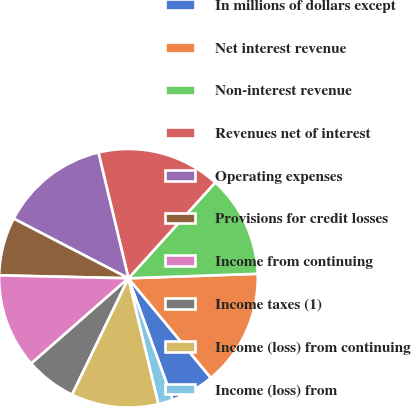Convert chart. <chart><loc_0><loc_0><loc_500><loc_500><pie_chart><fcel>In millions of dollars except<fcel>Net interest revenue<fcel>Non-interest revenue<fcel>Revenues net of interest<fcel>Operating expenses<fcel>Provisions for credit losses<fcel>Income from continuing<fcel>Income taxes (1)<fcel>Income (loss) from continuing<fcel>Income (loss) from<nl><fcel>5.45%<fcel>14.55%<fcel>12.73%<fcel>15.45%<fcel>13.64%<fcel>7.27%<fcel>11.82%<fcel>6.36%<fcel>10.91%<fcel>1.82%<nl></chart> 